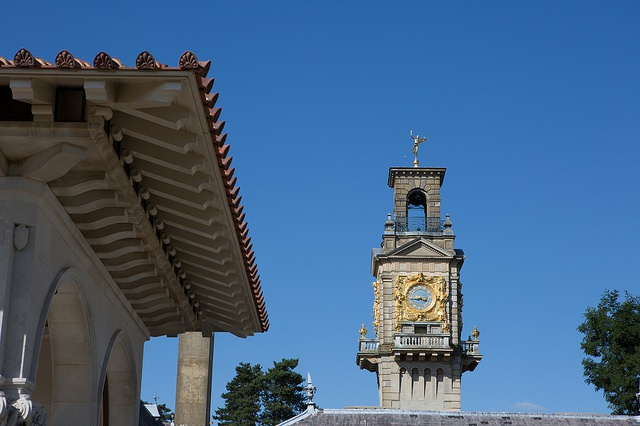Describe the objects in this image and their specific colors. I can see a clock in blue, tan, and darkgray tones in this image. 